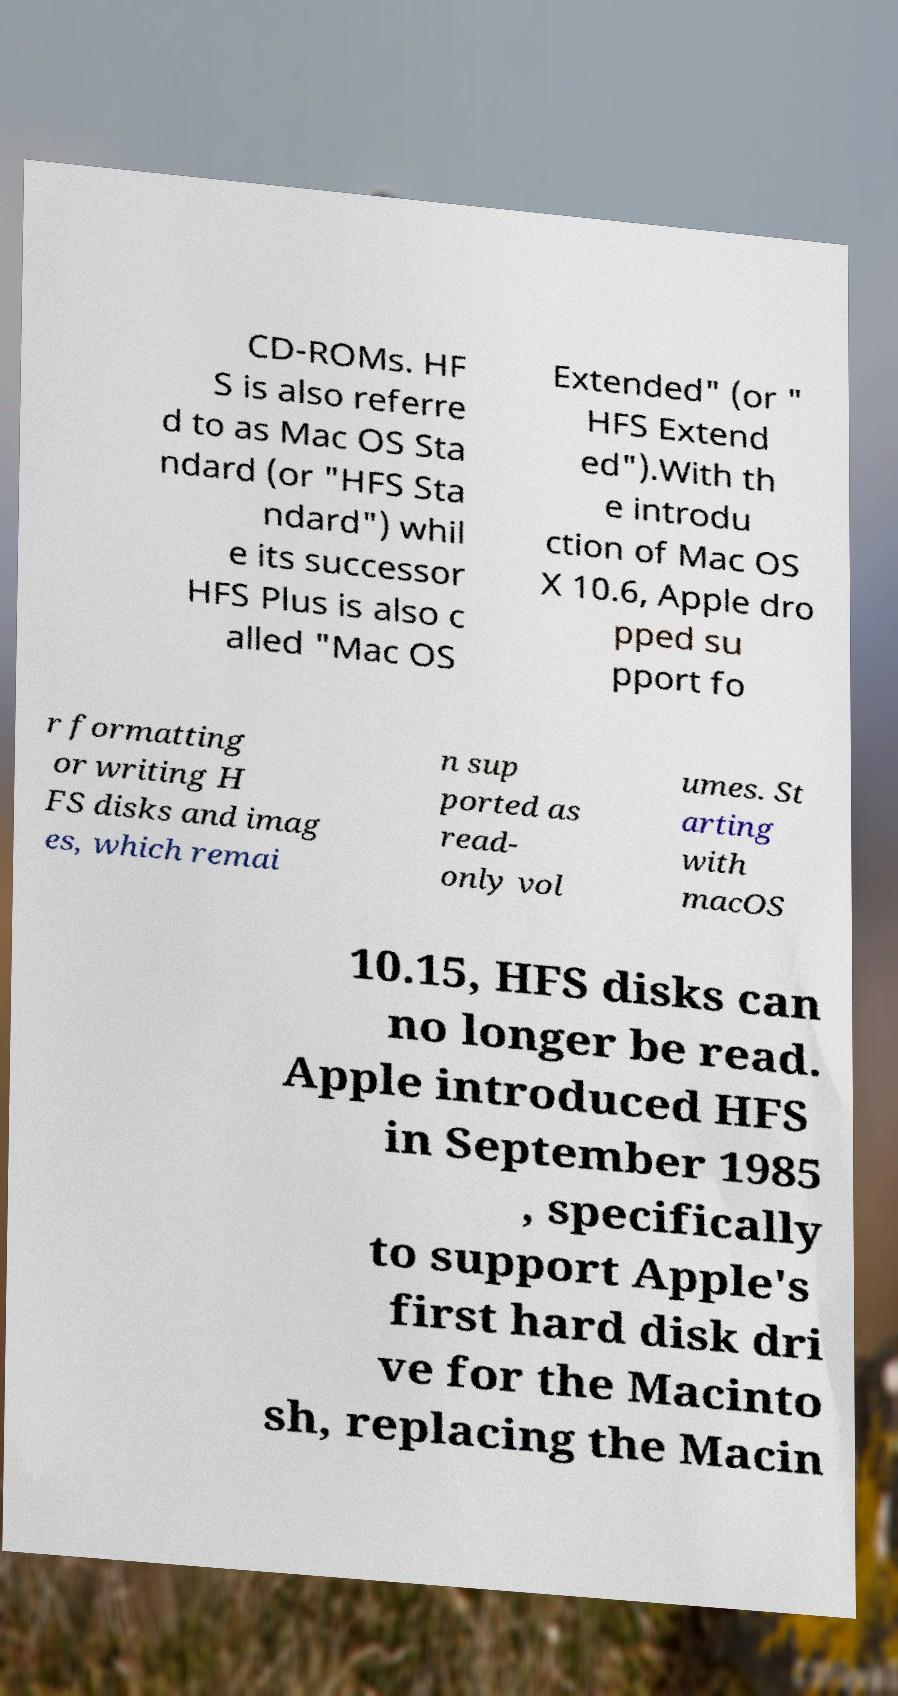Could you extract and type out the text from this image? CD-ROMs. HF S is also referre d to as Mac OS Sta ndard (or "HFS Sta ndard") whil e its successor HFS Plus is also c alled "Mac OS Extended" (or " HFS Extend ed").With th e introdu ction of Mac OS X 10.6, Apple dro pped su pport fo r formatting or writing H FS disks and imag es, which remai n sup ported as read- only vol umes. St arting with macOS 10.15, HFS disks can no longer be read. Apple introduced HFS in September 1985 , specifically to support Apple's first hard disk dri ve for the Macinto sh, replacing the Macin 